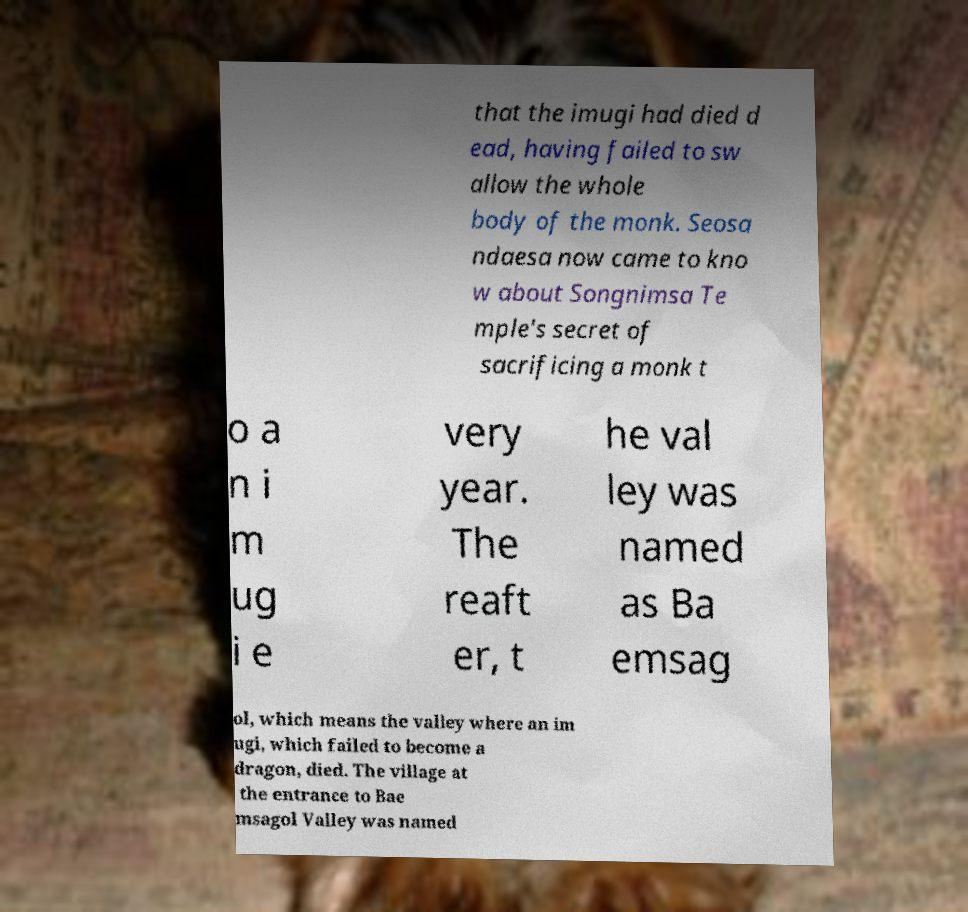I need the written content from this picture converted into text. Can you do that? that the imugi had died d ead, having failed to sw allow the whole body of the monk. Seosa ndaesa now came to kno w about Songnimsa Te mple's secret of sacrificing a monk t o a n i m ug i e very year. The reaft er, t he val ley was named as Ba emsag ol, which means the valley where an im ugi, which failed to become a dragon, died. The village at the entrance to Bae msagol Valley was named 